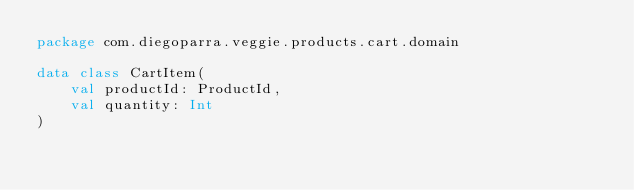<code> <loc_0><loc_0><loc_500><loc_500><_Kotlin_>package com.diegoparra.veggie.products.cart.domain

data class CartItem(
    val productId: ProductId,
    val quantity: Int
)</code> 